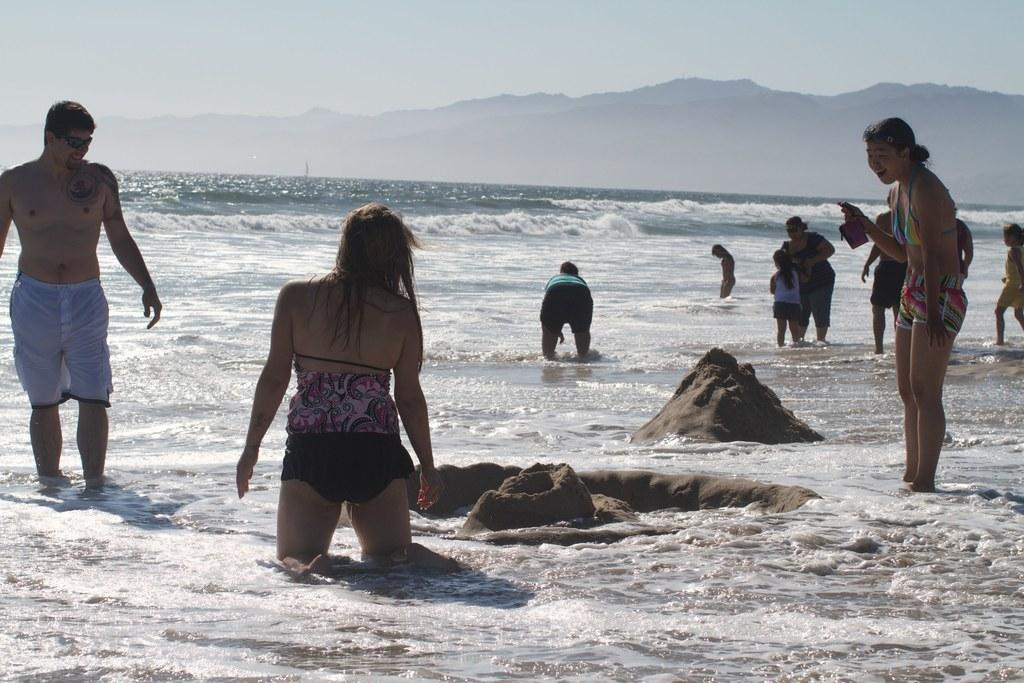What is the main subject of the image? The main subject of the image is people standing near a large water body. What can be seen in the foreground of the image? There are sand castles visible in the image. What is visible in the background of the image? There are mountains in the background of the image. How would you describe the sky in the image? The sky is visible in the image and appears cloudy. Can you tell me how many wrens are perched on the sand castles in the image? There are no wrens present in the image; it features people near a large water body, sand castles, mountains, and a cloudy sky. 